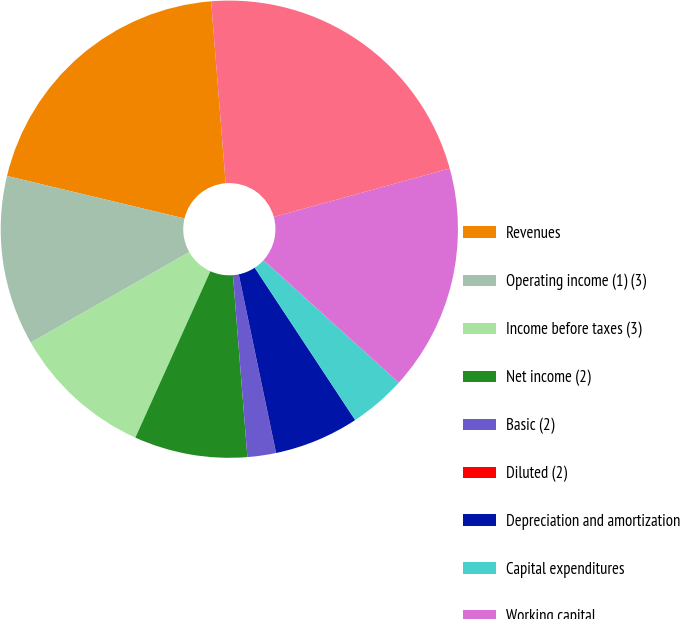Convert chart. <chart><loc_0><loc_0><loc_500><loc_500><pie_chart><fcel>Revenues<fcel>Operating income (1) (3)<fcel>Income before taxes (3)<fcel>Net income (2)<fcel>Basic (2)<fcel>Diluted (2)<fcel>Depreciation and amortization<fcel>Capital expenditures<fcel>Working capital<fcel>Total assets<nl><fcel>19.99%<fcel>12.0%<fcel>10.0%<fcel>8.0%<fcel>2.01%<fcel>0.01%<fcel>6.0%<fcel>4.01%<fcel>15.99%<fcel>21.99%<nl></chart> 